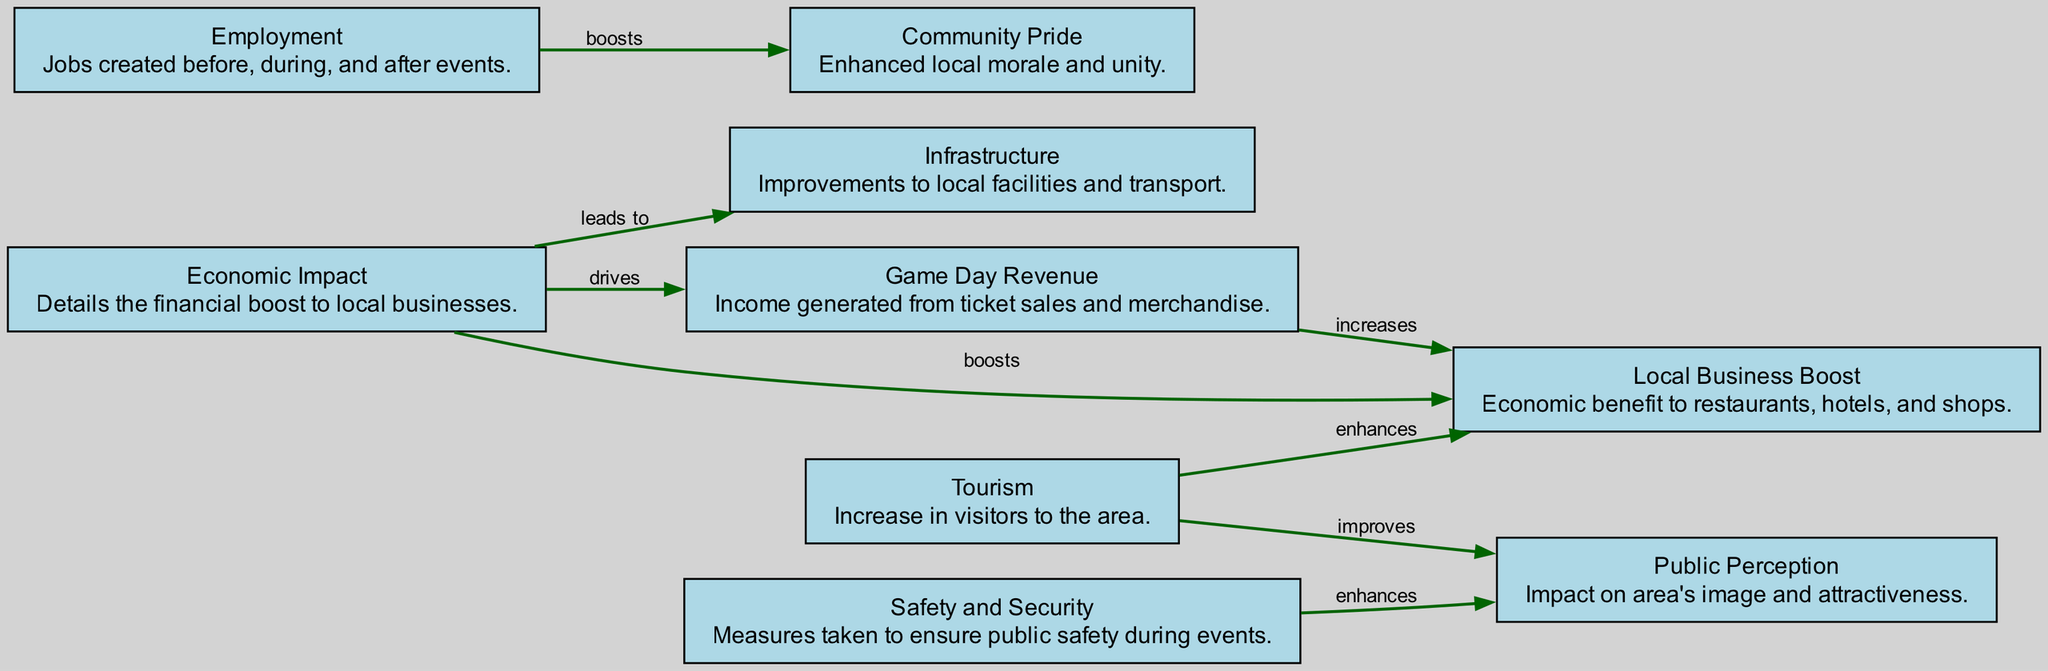What is the total number of nodes in the diagram? The diagram contains eight nodes, which represent various aspects of the socioeconomic impact of sporting events. By counting each listed node, we can confirm that there are indeed eight.
Answer: 8 What does the "Economic Impact" node boost? The "Economic Impact" node boosts local businesses according to the connection shown in the diagram. There is a direct arrow from "Economic Impact" to "Local Business Boost" labeled "boosts."
Answer: Local Business Boost How many edges are present in the diagram? There are eight edges that connect the nodes together. This can be counted by observing the arrows linking the different nodes in the diagram.
Answer: 8 What enhances "Public Perception"? "Tourism" enhances "Public Perception" as indicated by the arrow that goes from the "Tourism" node to "Public Perception," labeled "improves."
Answer: Tourism Which node is driven by "Game Day Revenue"? The "Game Day Revenue" node drives both "Local Business Boost" and contributes to "Economic Impact." This is indicated by the arrows directed from it to those nodes.
Answer: Local Business Boost What node is linked to "Safety and Security"? "Safety and Security" is linked to "Public Perception." The diagram shows an edge connecting these two nodes, indicating that safety measures impact how the area is perceived.
Answer: Public Perception Which factor is highlighted as increasing due to "Gameday Revenue"? "Local Business Boost" is highlighted as increasing due to "Gameday Revenue," indicated by the direct connection labeled "increases."
Answer: Local Business Boost How does "Employment" impact "Community Pride"? "Employment" boosts "Community Pride," as indicated by the arrow connecting these two nodes, which illustrates that job creation contributes to local morale.
Answer: Boosts 